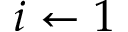Convert formula to latex. <formula><loc_0><loc_0><loc_500><loc_500>i \gets 1</formula> 